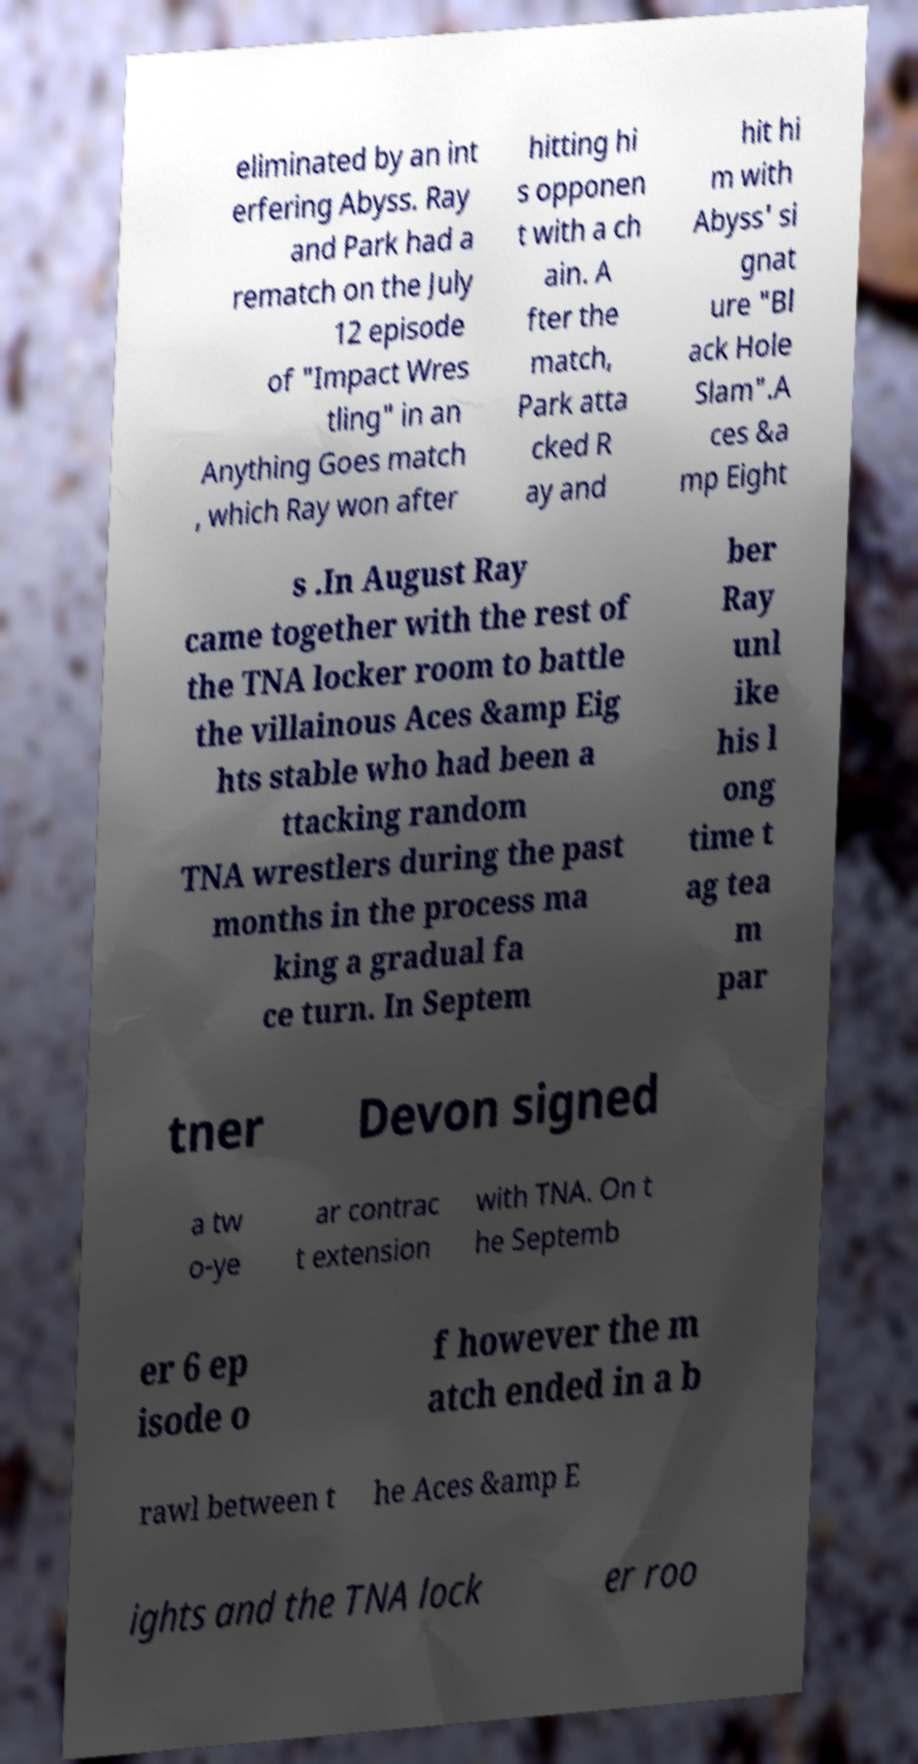What messages or text are displayed in this image? I need them in a readable, typed format. eliminated by an int erfering Abyss. Ray and Park had a rematch on the July 12 episode of "Impact Wres tling" in an Anything Goes match , which Ray won after hitting hi s opponen t with a ch ain. A fter the match, Park atta cked R ay and hit hi m with Abyss' si gnat ure "Bl ack Hole Slam".A ces &a mp Eight s .In August Ray came together with the rest of the TNA locker room to battle the villainous Aces &amp Eig hts stable who had been a ttacking random TNA wrestlers during the past months in the process ma king a gradual fa ce turn. In Septem ber Ray unl ike his l ong time t ag tea m par tner Devon signed a tw o-ye ar contrac t extension with TNA. On t he Septemb er 6 ep isode o f however the m atch ended in a b rawl between t he Aces &amp E ights and the TNA lock er roo 